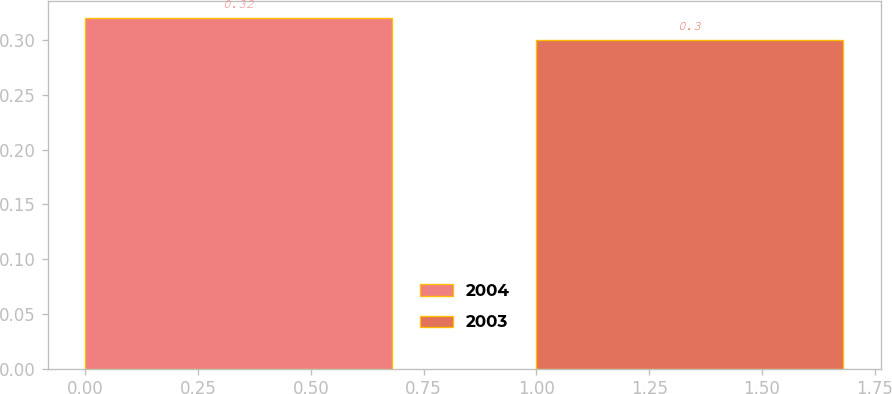Convert chart. <chart><loc_0><loc_0><loc_500><loc_500><bar_chart><fcel>2004<fcel>2003<nl><fcel>0.32<fcel>0.3<nl></chart> 